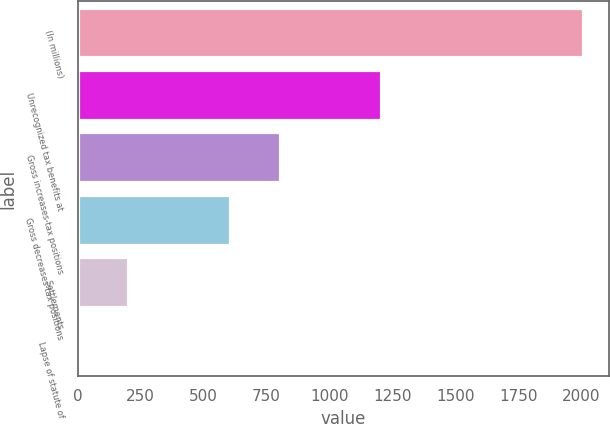Convert chart. <chart><loc_0><loc_0><loc_500><loc_500><bar_chart><fcel>(In millions)<fcel>Unrecognized tax benefits at<fcel>Gross increases-tax positions<fcel>Gross decreases-tax positions<fcel>Settlements<fcel>Lapse of statute of<nl><fcel>2009<fcel>1205.48<fcel>803.72<fcel>602.84<fcel>201.08<fcel>0.2<nl></chart> 